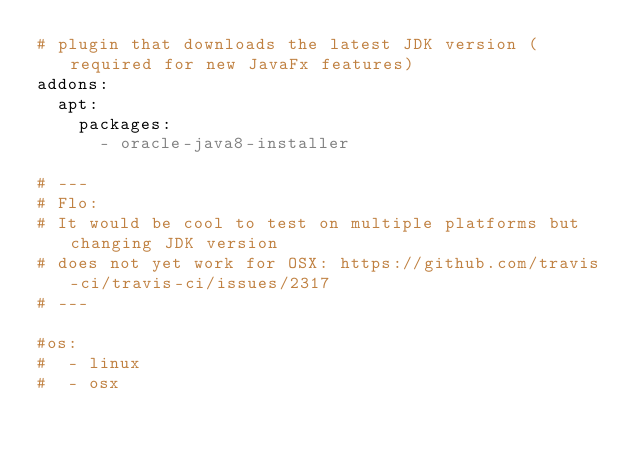Convert code to text. <code><loc_0><loc_0><loc_500><loc_500><_YAML_># plugin that downloads the latest JDK version (required for new JavaFx features)
addons:
  apt:
    packages:
      - oracle-java8-installer

# --- 
# Flo:
# It would be cool to test on multiple platforms but changing JDK version 
# does not yet work for OSX: https://github.com/travis-ci/travis-ci/issues/2317
# --- 

#os:
#  - linux
#  - osx
</code> 